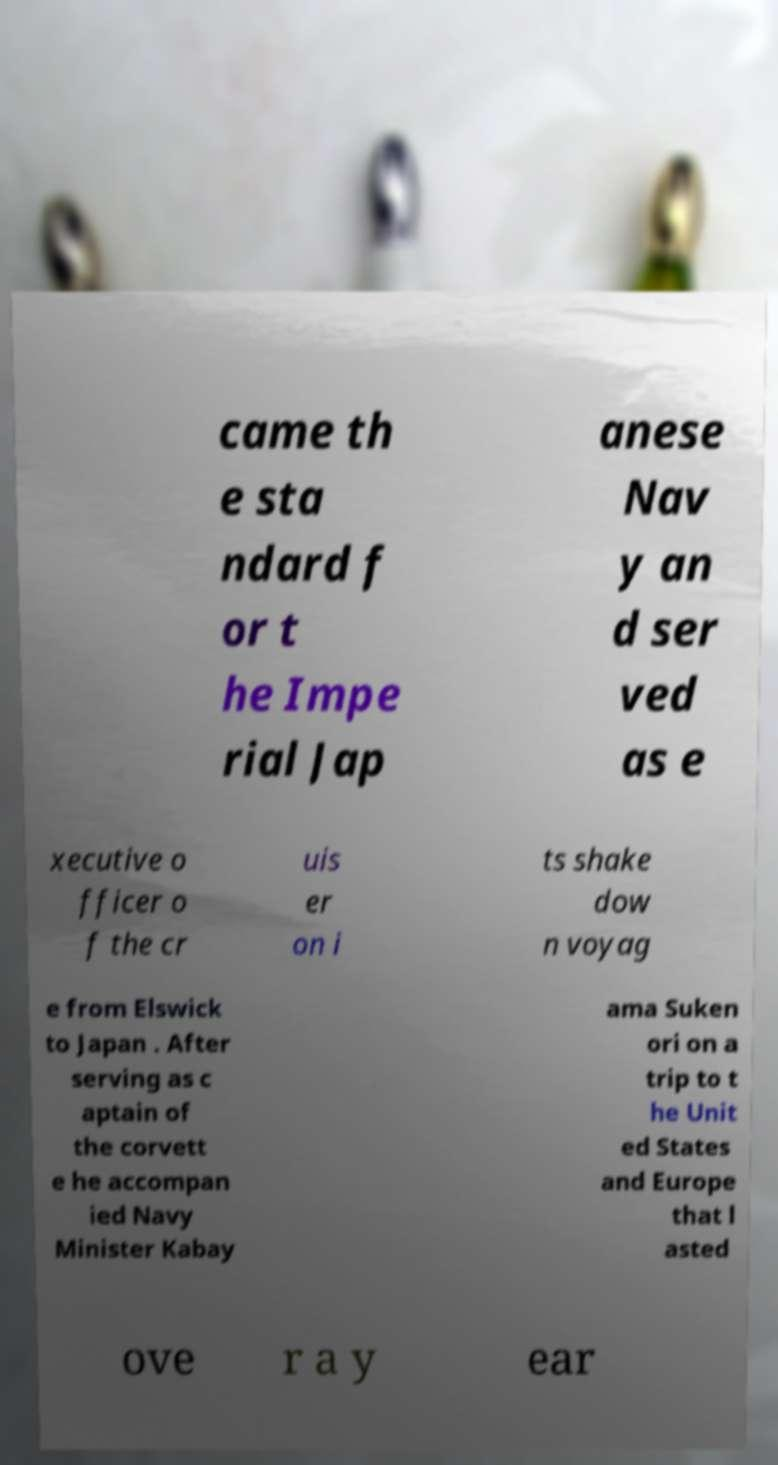Could you extract and type out the text from this image? came th e sta ndard f or t he Impe rial Jap anese Nav y an d ser ved as e xecutive o fficer o f the cr uis er on i ts shake dow n voyag e from Elswick to Japan . After serving as c aptain of the corvett e he accompan ied Navy Minister Kabay ama Suken ori on a trip to t he Unit ed States and Europe that l asted ove r a y ear 